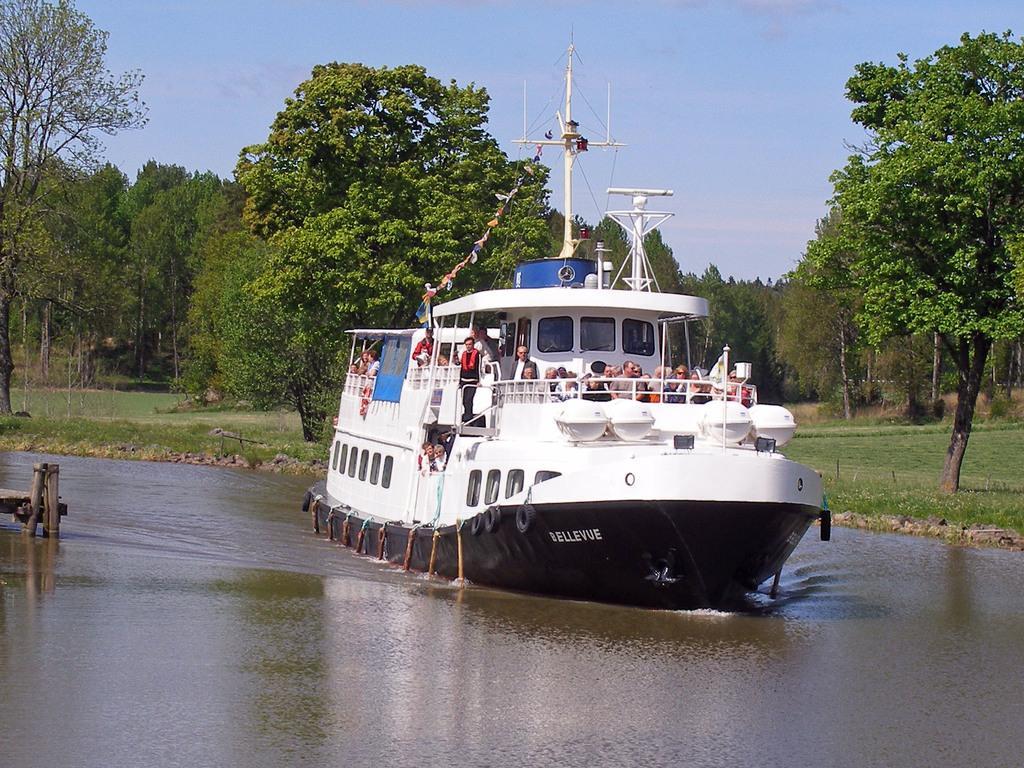Please provide a concise description of this image. As we can see in the image there are few people on boat. There is water, grass, trees and sky. 